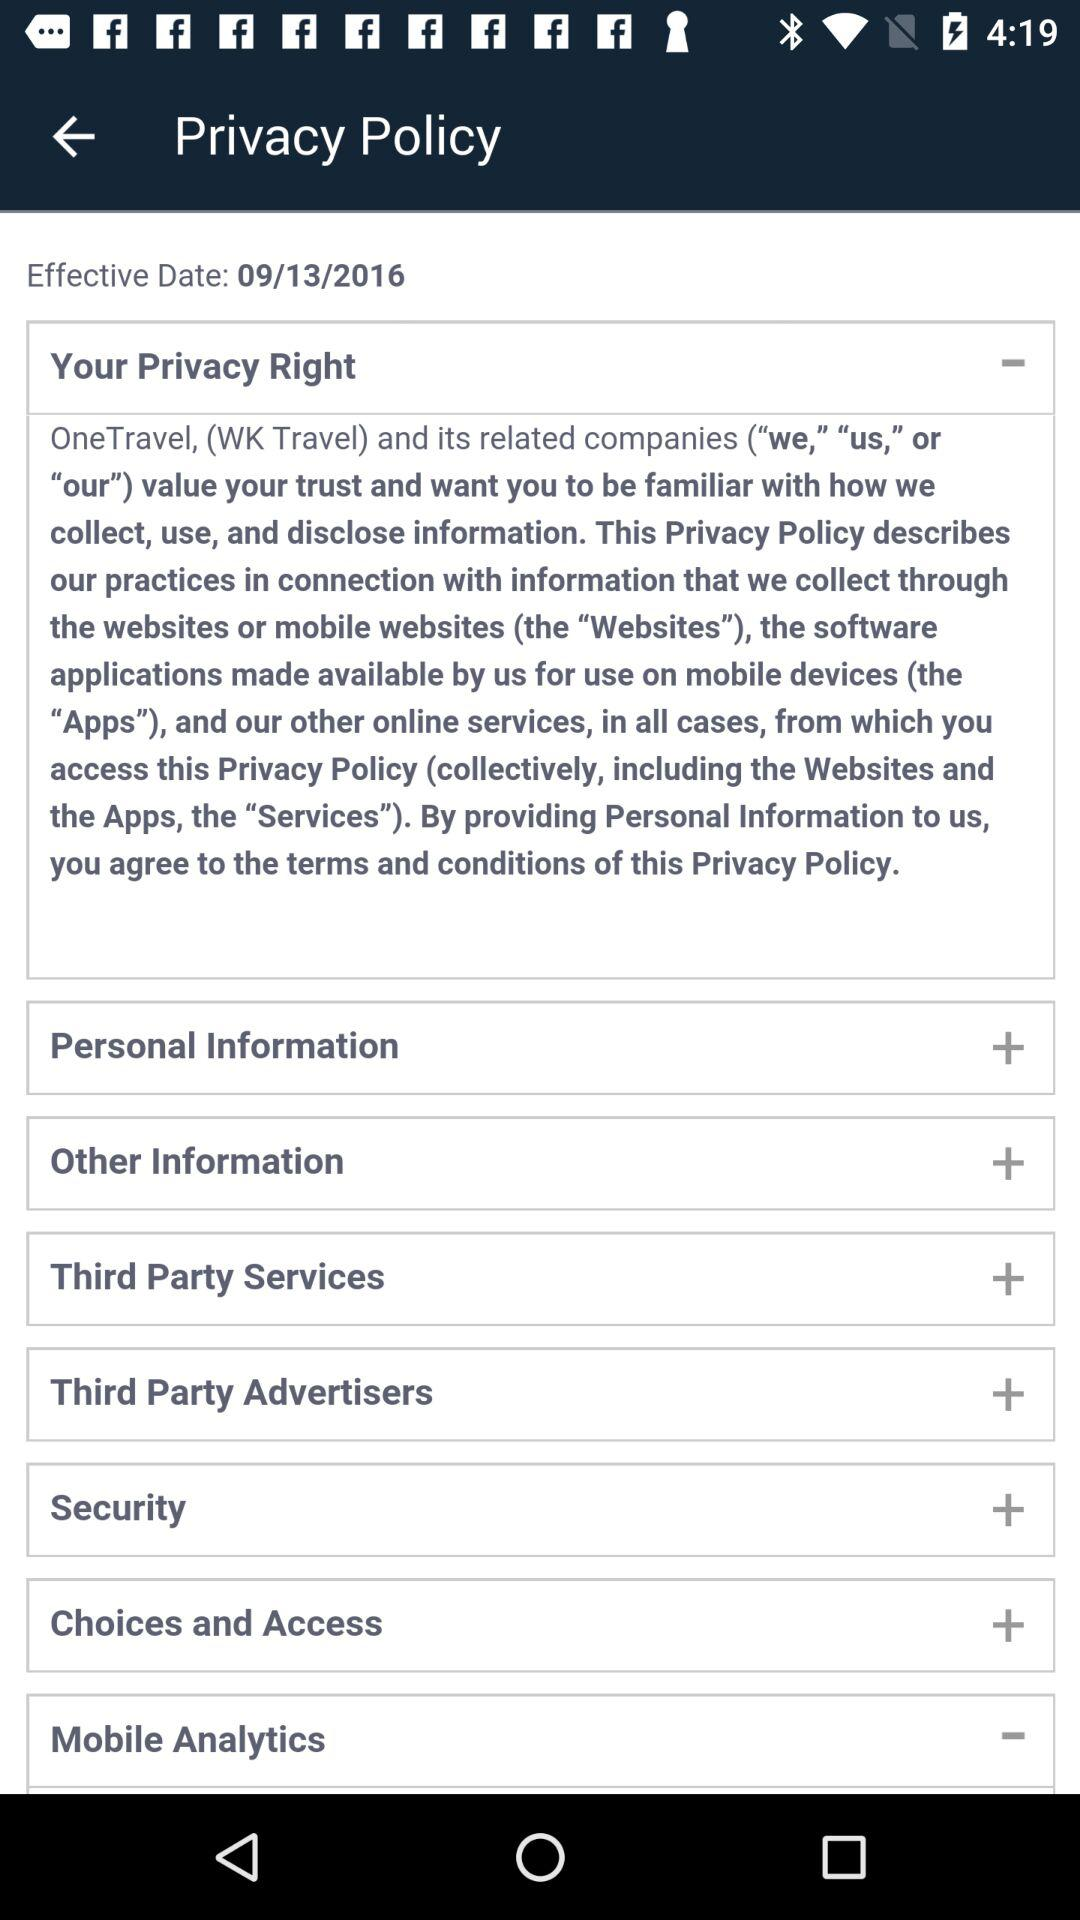What is the date? The date is September 13, 2016. 